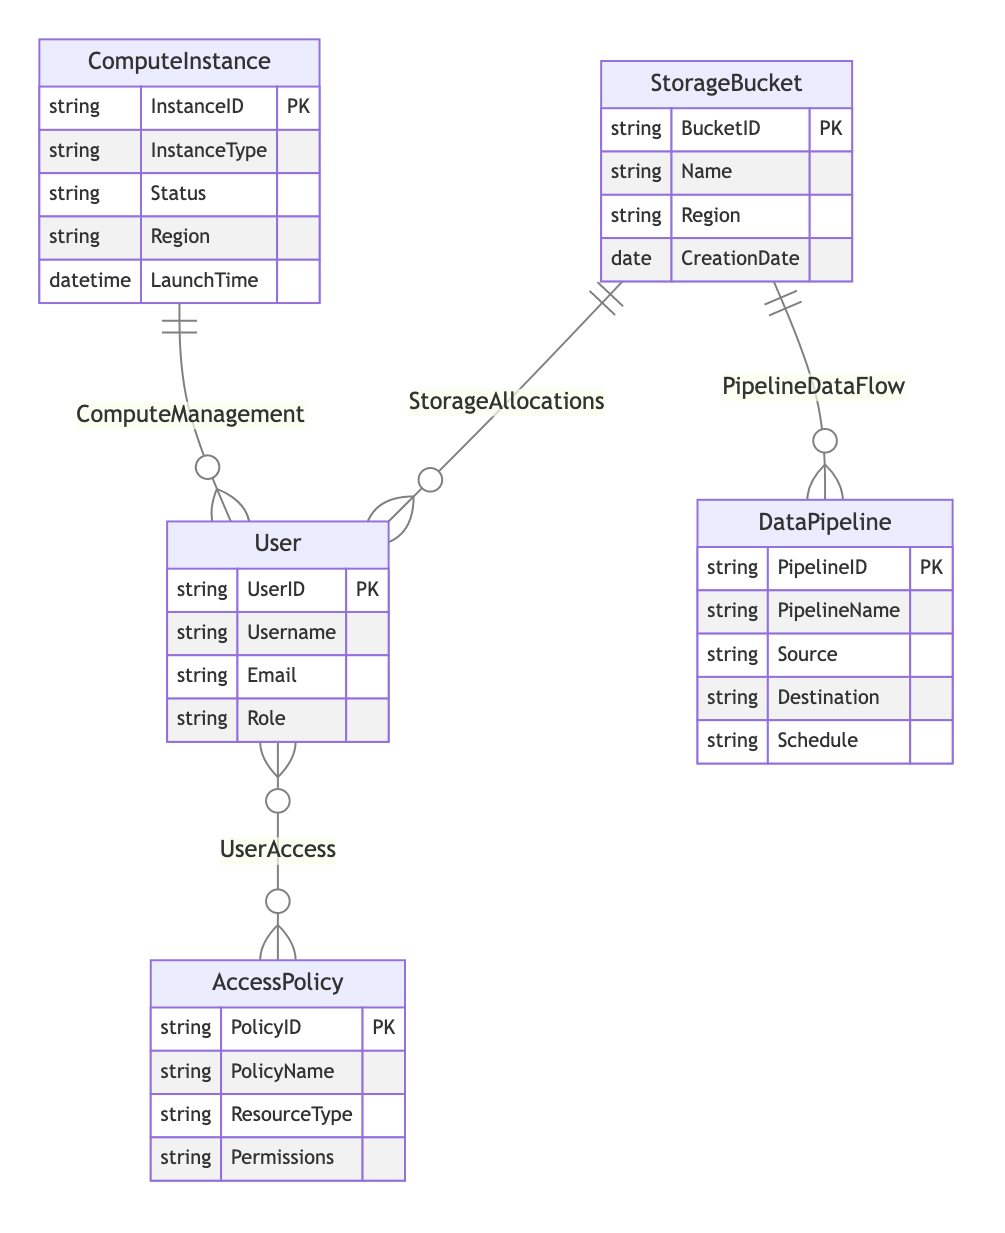What entities are present in the diagram? The diagram lists five entities: StorageBucket, ComputeInstance, User, AccessPolicy, and DataPipeline.
Answer: StorageBucket, ComputeInstance, User, AccessPolicy, DataPipeline How many relationships are represented in the diagram? There are four relationships indicated in the diagram: UserAccess, StorageAllocations, ComputeManagement, and PipelineDataFlow.
Answer: Four What type of relationship exists between User and AccessPolicy? The diagram shows a many-to-many relationship between User and AccessPolicy. This means that one user can have multiple access policies and one access policy can be associated with multiple users.
Answer: Many-to-many How many attributes does the StorageBucket entity have? StorageBucket has four attributes: BucketID, Name, Region, and CreationDate.
Answer: Four Which entity has the attribute 'InstanceID'? The attribute 'InstanceID' belongs to the ComputeInstance entity as per the diagram.
Answer: ComputeInstance What is the cardinality of the relationship between User and ComputeInstance? The relationship between User and ComputeInstance is one-to-many, indicating that a single user can manage multiple compute instances.
Answer: One-to-many Which entities are connected by the PipelineDataFlow relationship? The PipelineDataFlow relationship connects the DataPipeline entity to the StorageBucket entity, indicating that data is flowing from a pipeline to a storage bucket.
Answer: DataPipeline and StorageBucket What does the UserAccess relationship represent? The UserAccess relationship represents the association between users and the access policies they have, indicating which policies are available to which users.
Answer: User and AccessPolicy What is the primary key of the User entity? The primary key of the User entity is UserID, which uniquely identifies each user in the system.
Answer: UserID 